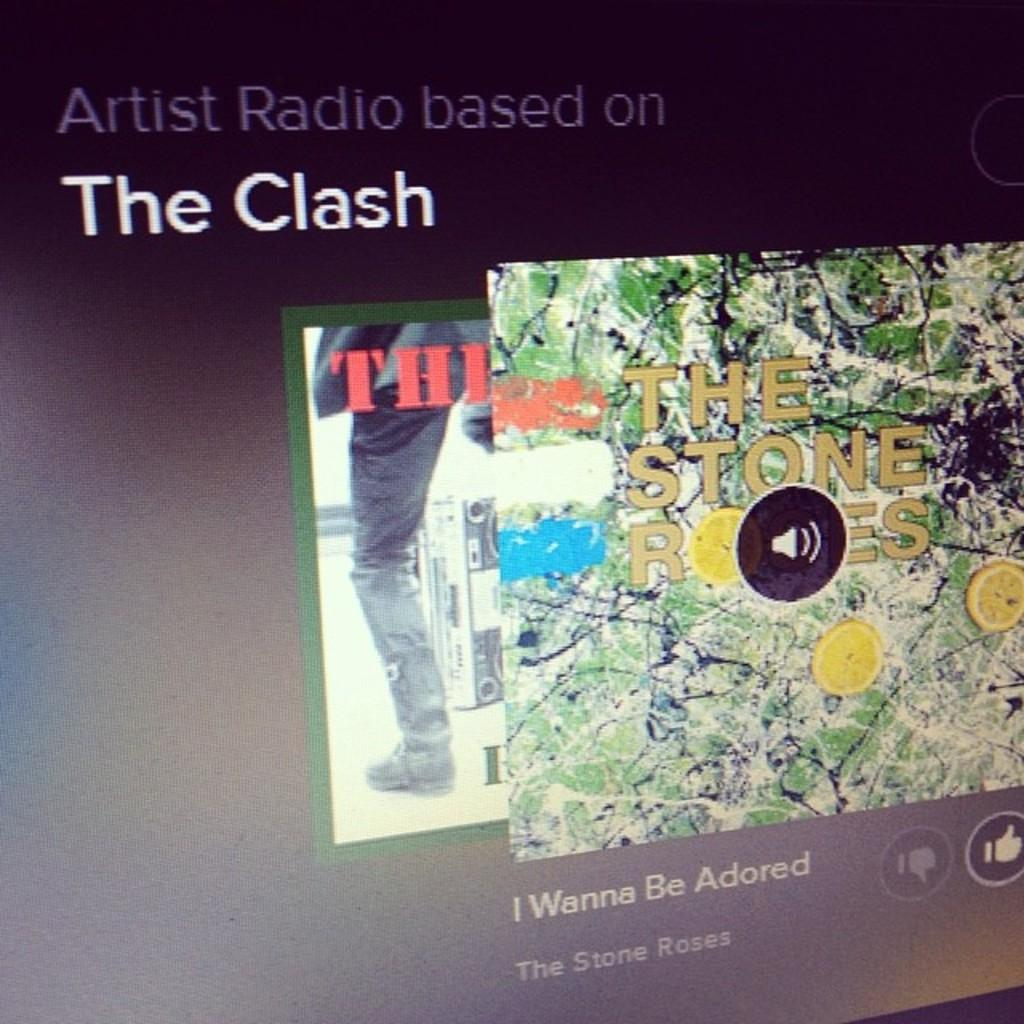What is the main object in the image? There is a screen in the image. What can be seen on the screen? The screen contains text and images. What type of teaching method is being demonstrated in the image? There is no teaching method or any indication of teaching in the image; it only shows a screen with text and images. 